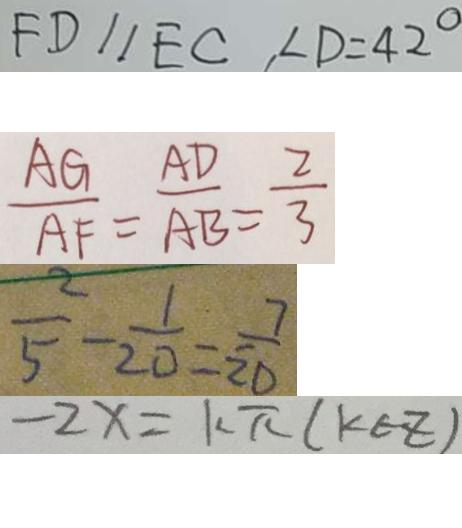<formula> <loc_0><loc_0><loc_500><loc_500>F D / / E C , \angle D = 4 2 ^ { \circ } 
 \frac { A G } { A F } = \frac { A D } { A B } = \frac { 2 } { 3 } 
 \frac { 2 } { 5 } - \frac { 1 } { 2 0 } = \frac { 7 } { 2 0 } 
 - 2 x = k \pi ( k \in z )</formula> 